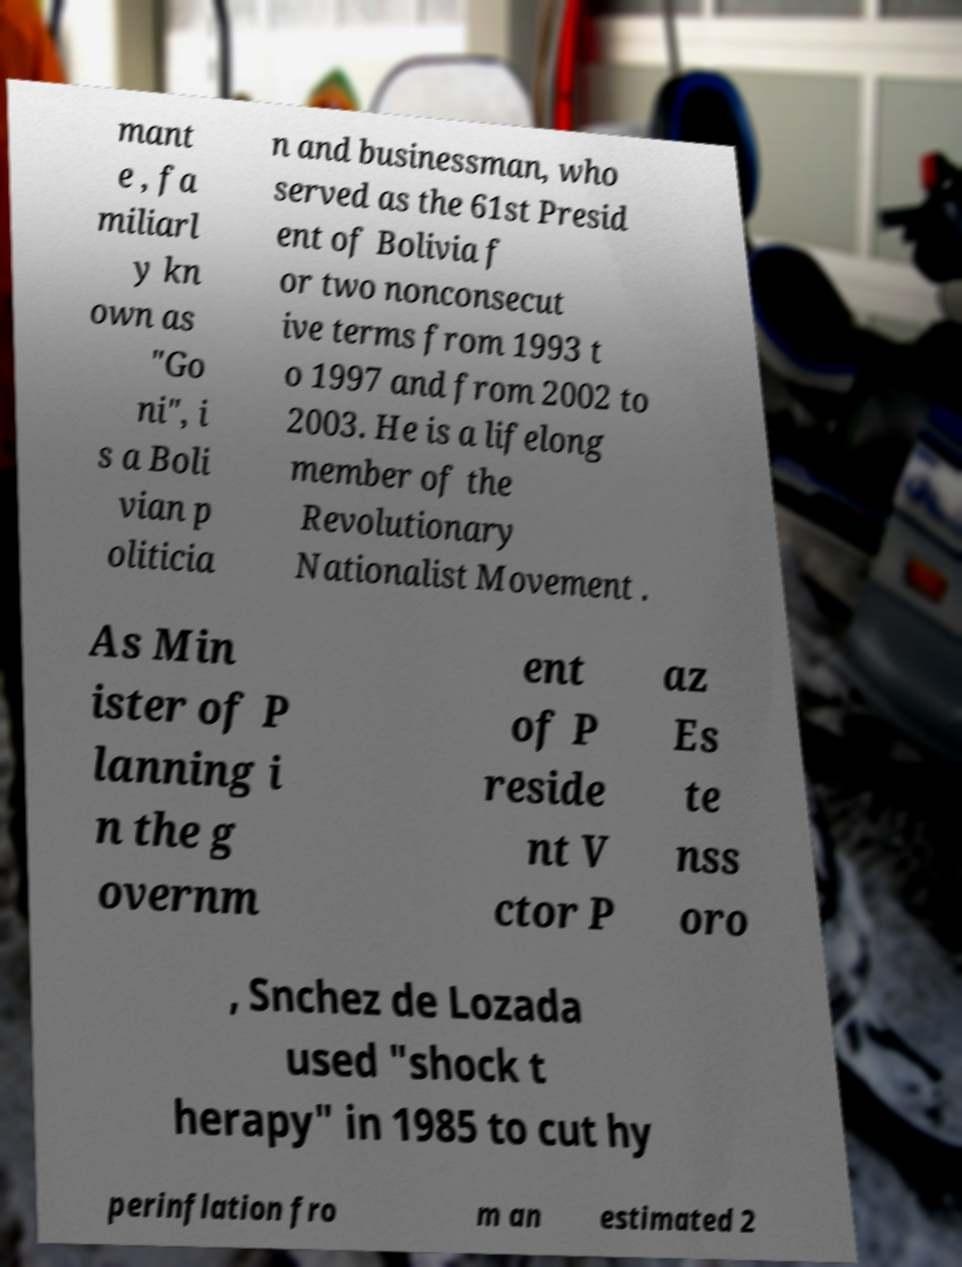Can you accurately transcribe the text from the provided image for me? mant e , fa miliarl y kn own as "Go ni", i s a Boli vian p oliticia n and businessman, who served as the 61st Presid ent of Bolivia f or two nonconsecut ive terms from 1993 t o 1997 and from 2002 to 2003. He is a lifelong member of the Revolutionary Nationalist Movement . As Min ister of P lanning i n the g overnm ent of P reside nt V ctor P az Es te nss oro , Snchez de Lozada used "shock t herapy" in 1985 to cut hy perinflation fro m an estimated 2 